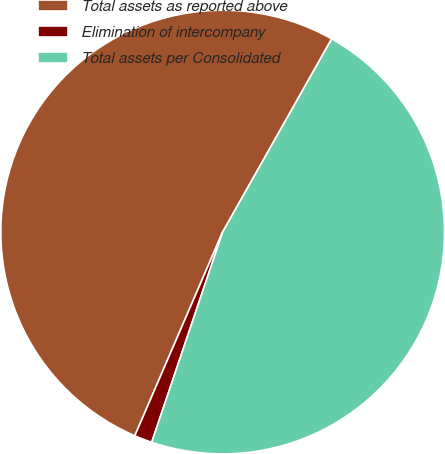<chart> <loc_0><loc_0><loc_500><loc_500><pie_chart><fcel>Total assets as reported above<fcel>Elimination of intercompany<fcel>Total assets per Consolidated<nl><fcel>51.7%<fcel>1.3%<fcel>47.0%<nl></chart> 